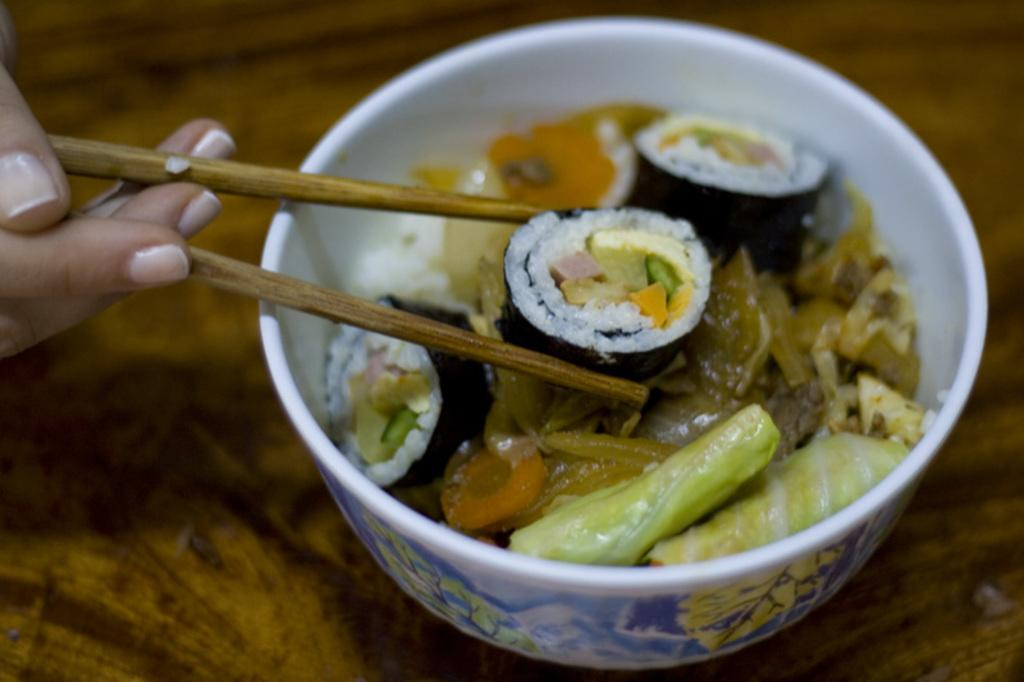What is in the bowl that is visible in the image? The bowl contains food. What is being used to eat the food in the bowl? There is a hand holding chopsticks in the image. What level of experience does the root have in the image? There is no root present in the image, so it is not possible to determine its level of experience. 